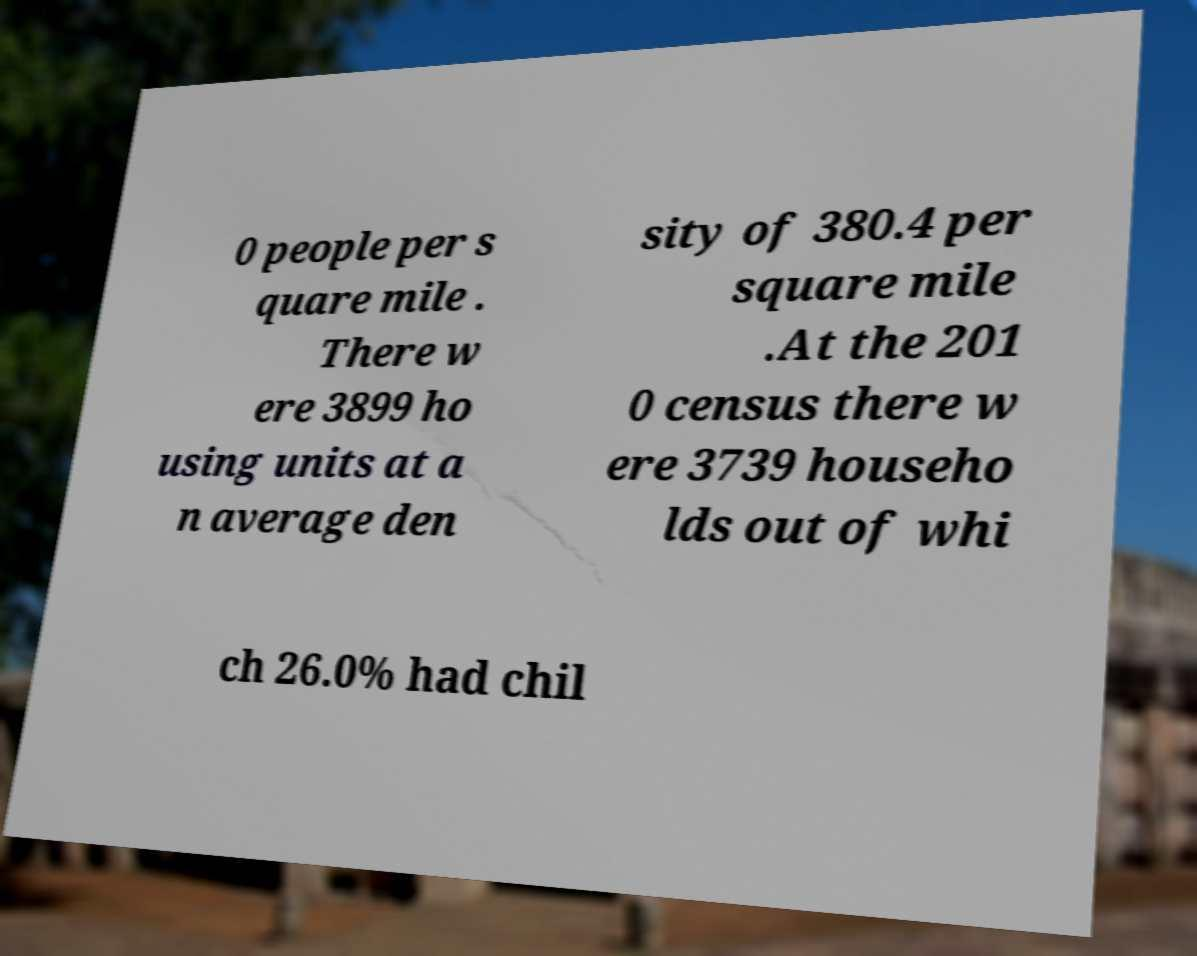Can you read and provide the text displayed in the image?This photo seems to have some interesting text. Can you extract and type it out for me? 0 people per s quare mile . There w ere 3899 ho using units at a n average den sity of 380.4 per square mile .At the 201 0 census there w ere 3739 househo lds out of whi ch 26.0% had chil 